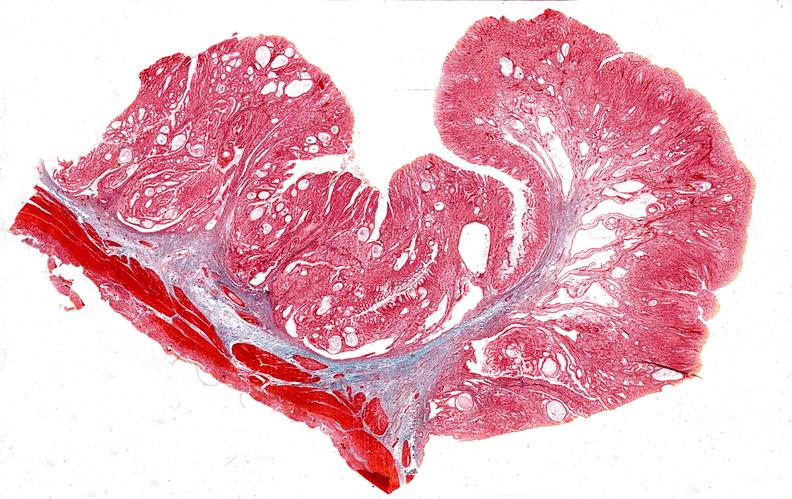does heel ulcer show stomach, giant rugose hyperplasia?
Answer the question using a single word or phrase. No 